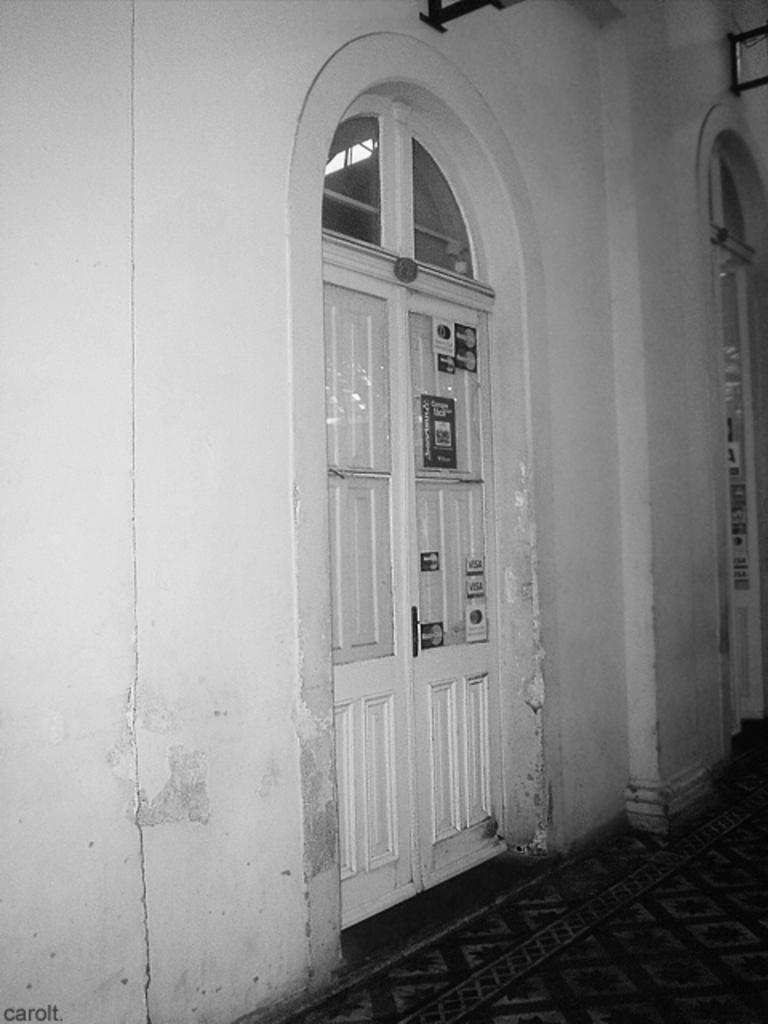How would you summarize this image in a sentence or two? In this image, we can see the wall and a door, there is a carpet on the floor. 